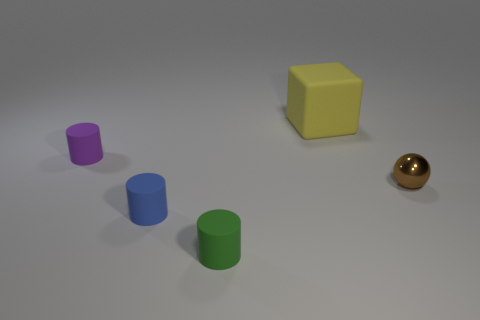Add 3 purple matte things. How many objects exist? 8 Subtract all cubes. How many objects are left? 4 Add 4 small green matte things. How many small green matte things are left? 5 Add 1 yellow rubber things. How many yellow rubber things exist? 2 Subtract 1 purple cylinders. How many objects are left? 4 Subtract all big gray matte spheres. Subtract all cylinders. How many objects are left? 2 